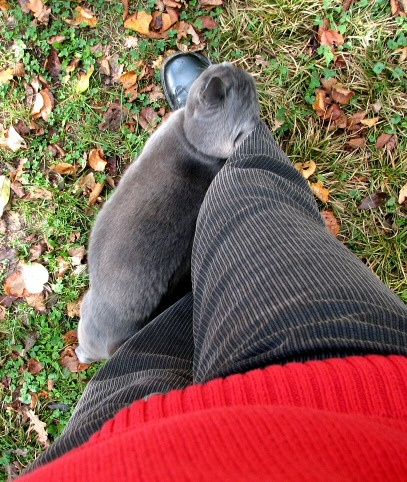Describe the objects in this image and their specific colors. I can see people in olive, red, gray, and black tones and cat in olive, darkgray, gray, black, and lightgray tones in this image. 